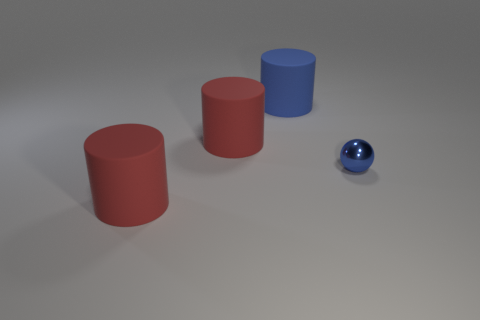What number of objects are in front of the large blue object and to the left of the small blue sphere?
Make the answer very short. 2. What number of tiny spheres are made of the same material as the tiny blue object?
Make the answer very short. 0. Are there fewer big yellow cubes than small blue objects?
Your answer should be very brief. Yes. There is a blue object that is in front of the large red rubber thing to the right of the big red matte cylinder in front of the blue metal thing; what is it made of?
Give a very brief answer. Metal. What material is the blue ball?
Your answer should be very brief. Metal. There is a matte object in front of the small blue thing; is it the same color as the thing that is to the right of the big blue object?
Keep it short and to the point. No. Are there more tiny metal objects than red cylinders?
Make the answer very short. No. What number of tiny things are the same color as the tiny metal ball?
Your response must be concise. 0. What is the cylinder that is behind the blue sphere and in front of the blue rubber cylinder made of?
Give a very brief answer. Rubber. Do the blue object that is left of the small sphere and the red cylinder that is behind the tiny blue metallic ball have the same material?
Provide a succinct answer. Yes. 